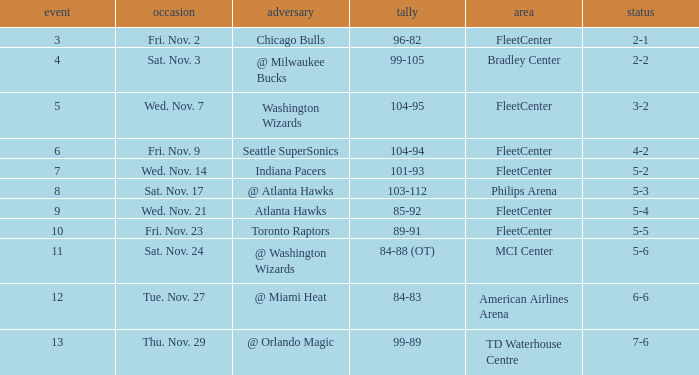Help me parse the entirety of this table. {'header': ['event', 'occasion', 'adversary', 'tally', 'area', 'status'], 'rows': [['3', 'Fri. Nov. 2', 'Chicago Bulls', '96-82', 'FleetCenter', '2-1'], ['4', 'Sat. Nov. 3', '@ Milwaukee Bucks', '99-105', 'Bradley Center', '2-2'], ['5', 'Wed. Nov. 7', 'Washington Wizards', '104-95', 'FleetCenter', '3-2'], ['6', 'Fri. Nov. 9', 'Seattle SuperSonics', '104-94', 'FleetCenter', '4-2'], ['7', 'Wed. Nov. 14', 'Indiana Pacers', '101-93', 'FleetCenter', '5-2'], ['8', 'Sat. Nov. 17', '@ Atlanta Hawks', '103-112', 'Philips Arena', '5-3'], ['9', 'Wed. Nov. 21', 'Atlanta Hawks', '85-92', 'FleetCenter', '5-4'], ['10', 'Fri. Nov. 23', 'Toronto Raptors', '89-91', 'FleetCenter', '5-5'], ['11', 'Sat. Nov. 24', '@ Washington Wizards', '84-88 (OT)', 'MCI Center', '5-6'], ['12', 'Tue. Nov. 27', '@ Miami Heat', '84-83', 'American Airlines Arena', '6-6'], ['13', 'Thu. Nov. 29', '@ Orlando Magic', '99-89', 'TD Waterhouse Centre', '7-6']]} Which opponent has a score of 84-88 (ot)? @ Washington Wizards. 